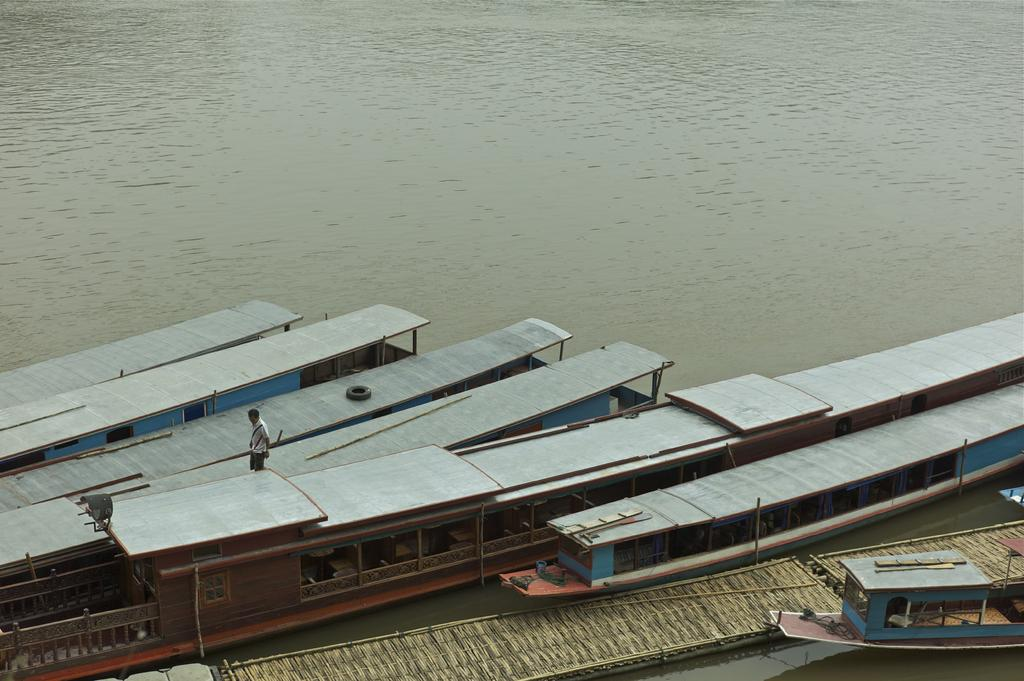What is in the water in the foreground of the image? There are boats in the water in the foreground of the image. Can you describe the person visible in the image? There is a person visible in the image, but their appearance or actions are not specified. What time of day is the image likely taken? The image is likely taken during the day, as there is no indication of darkness or artificial lighting. What type of body of water might the image be near? The image is likely taken near a lake, as boats are typically found in lakes or other calm bodies of water. What type of cloth is being used to cover the family in the image? There is no family or cloth present in the image; it features boats in the water and a person. What sense is being evoked by the image? The image does not evoke a specific sense, as it is a visual representation and does not include any auditory, tactile, or olfactory elements. 